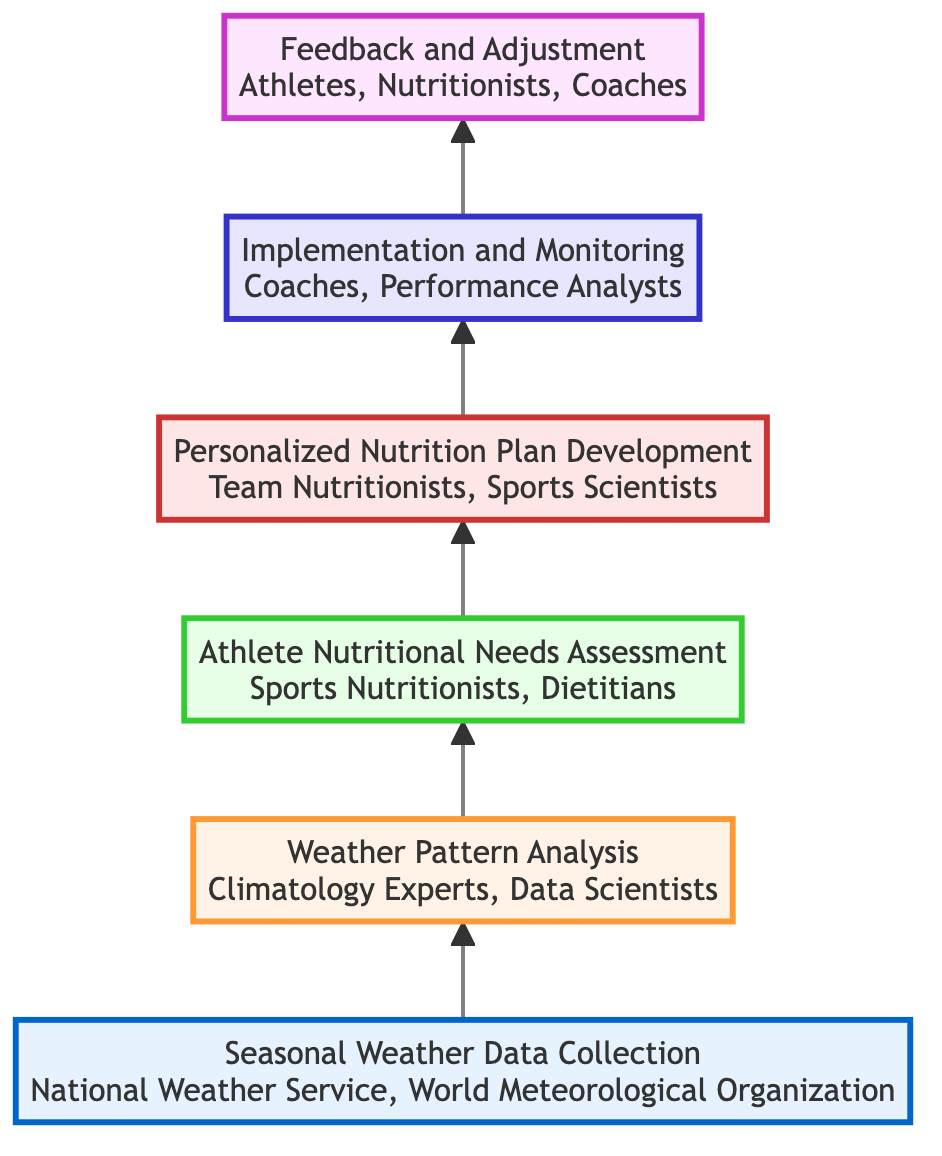What is the first step in the process? The first step, as indicated at the bottom of the flow chart, is "Seasonal Weather Data Collection." This is the starting point before moving up to the next level.
Answer: Seasonal Weather Data Collection Who is involved in the "Personalized Nutrition Plan Development"? The diagram specifies that "Team Nutritionists" and "Sports Scientists" are responsible for this step, making them the key players in developing personalized plans.
Answer: Team Nutritionists, Sports Scientists How many levels are in the flow chart? The diagram consists of six levels, as each sequential step from the beginning to the end has a distinct level represented.
Answer: Six What influences "Athlete Nutritional Needs Assessment"? The "Athlete Nutritional Needs Assessment" is influenced by the "Weather Pattern Analysis." This connection shows that understanding weather patterns directly affects how nutritional needs are evaluated.
Answer: Weather Pattern Analysis Which level involves monitoring athletes' performance? The level focused on monitoring athletes' performance is "Implementation and Monitoring," which includes coaches and performance analysts. This step comes after developing personalized nutrition plans.
Answer: Implementation and Monitoring What do athletes provide feedback on? Athletes provide feedback on "Performance," which is part of the "Feedback and Adjustment" level, indicating that their experiences are gathered to refine nutrition strategies.
Answer: Performance If we follow the flow chart from top to bottom, what is the last step? The last step at the top of the flow chart is "Feedback and Adjustment," concluding the sequential process of integrating weather patterns into nutritional programs.
Answer: Feedback and Adjustment What are the entities involved in "Weather Pattern Analysis"? The entities involved in "Weather Pattern Analysis" are "Climatology Experts" and "Data Scientists," who analyze the data collected for trends and patterns.
Answer: Climatology Experts, Data Scientists Which step comes directly after "Athlete Nutritional Needs Assessment"? The step that follows directly after "Athlete Nutritional Needs Assessment" is "Personalized Nutrition Plan Development," indicating a progression in the plan's development phases.
Answer: Personalized Nutrition Plan Development 